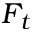Convert formula to latex. <formula><loc_0><loc_0><loc_500><loc_500>F _ { t }</formula> 